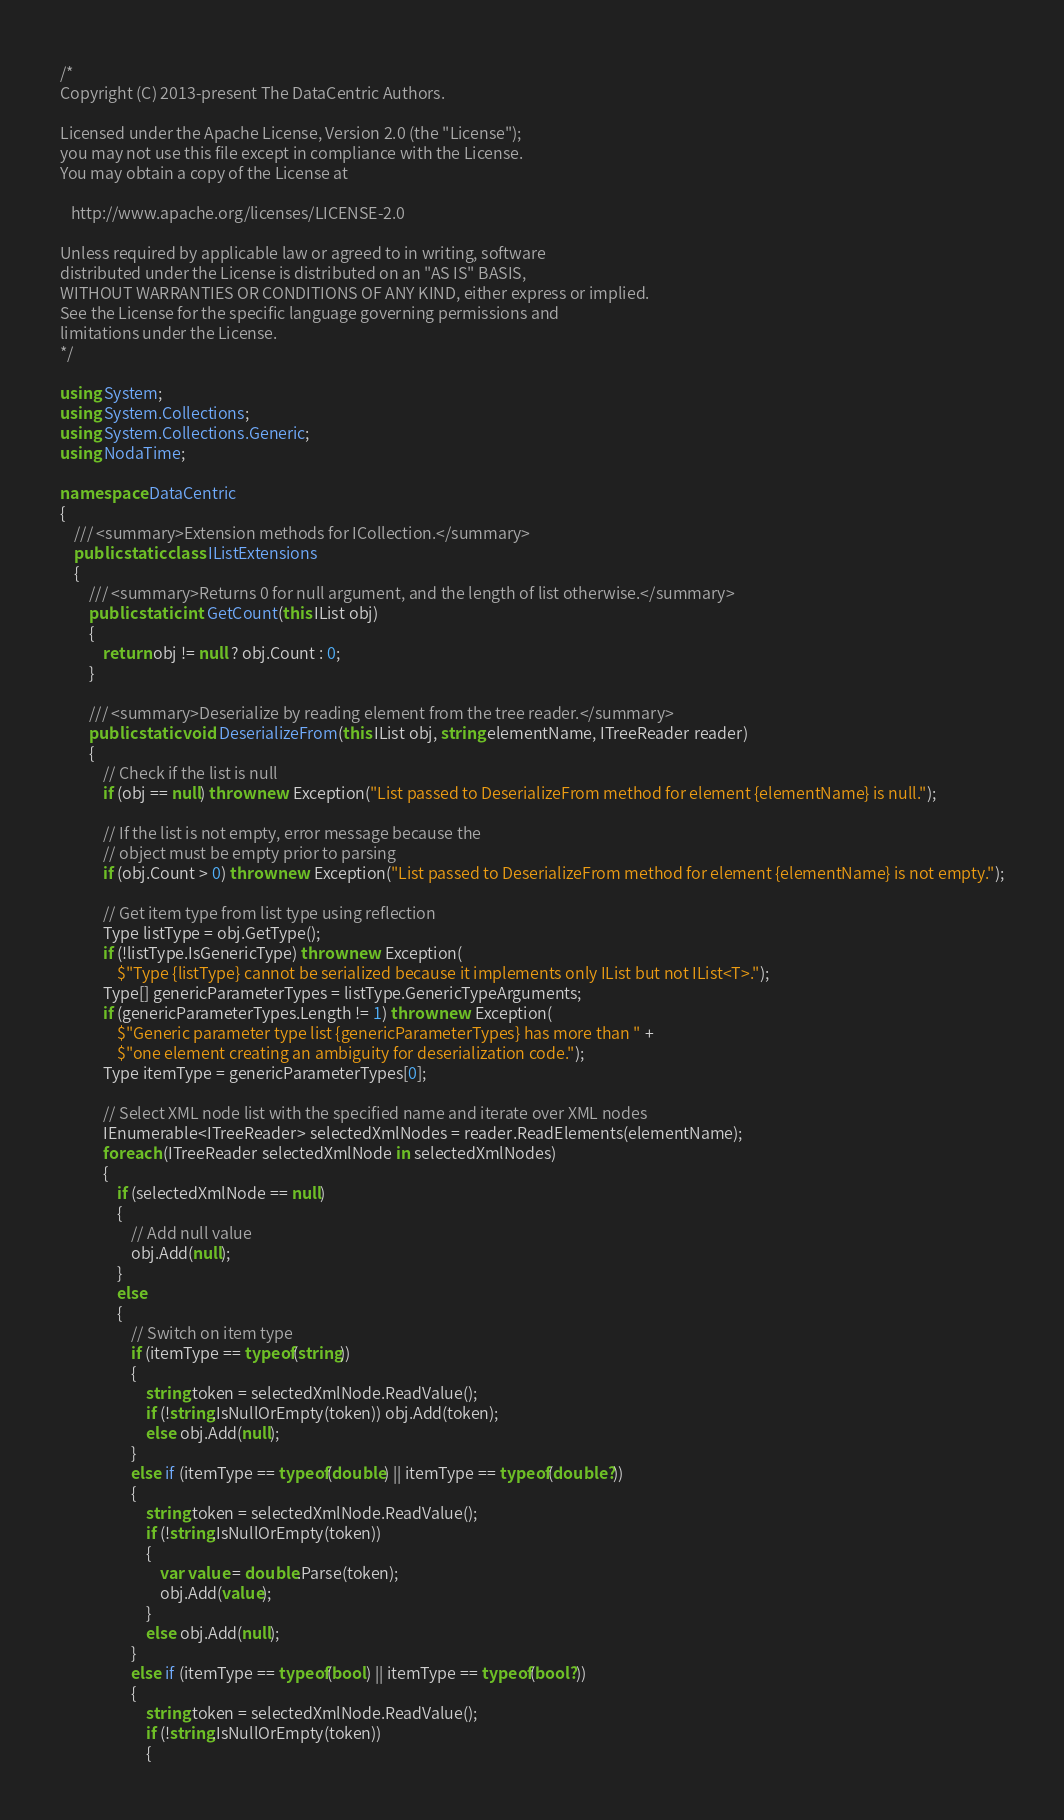<code> <loc_0><loc_0><loc_500><loc_500><_C#_>/*
Copyright (C) 2013-present The DataCentric Authors.

Licensed under the Apache License, Version 2.0 (the "License");
you may not use this file except in compliance with the License.
You may obtain a copy of the License at

   http://www.apache.org/licenses/LICENSE-2.0

Unless required by applicable law or agreed to in writing, software
distributed under the License is distributed on an "AS IS" BASIS,
WITHOUT WARRANTIES OR CONDITIONS OF ANY KIND, either express or implied.
See the License for the specific language governing permissions and
limitations under the License.
*/

using System;
using System.Collections;
using System.Collections.Generic;
using NodaTime;

namespace DataCentric
{
    /// <summary>Extension methods for ICollection.</summary>
    public static class IListExtensions
    {
        /// <summary>Returns 0 for null argument, and the length of list otherwise.</summary>
        public static int GetCount(this IList obj)
        {
            return obj != null ? obj.Count : 0;
        }

        /// <summary>Deserialize by reading element from the tree reader.</summary>
        public static void DeserializeFrom(this IList obj, string elementName, ITreeReader reader)
        {
            // Check if the list is null
            if (obj == null) throw new Exception("List passed to DeserializeFrom method for element {elementName} is null.");

            // If the list is not empty, error message because the
            // object must be empty prior to parsing
            if (obj.Count > 0) throw new Exception("List passed to DeserializeFrom method for element {elementName} is not empty.");

            // Get item type from list type using reflection
            Type listType = obj.GetType();
            if (!listType.IsGenericType) throw new Exception(
                $"Type {listType} cannot be serialized because it implements only IList but not IList<T>.");
            Type[] genericParameterTypes = listType.GenericTypeArguments;
            if (genericParameterTypes.Length != 1) throw new Exception(
                $"Generic parameter type list {genericParameterTypes} has more than " +
                $"one element creating an ambiguity for deserialization code.");
            Type itemType = genericParameterTypes[0];

            // Select XML node list with the specified name and iterate over XML nodes
            IEnumerable<ITreeReader> selectedXmlNodes = reader.ReadElements(elementName);
            foreach (ITreeReader selectedXmlNode in selectedXmlNodes)
            {
                if (selectedXmlNode == null)
                {
                    // Add null value
                    obj.Add(null);
                }
                else
                {
                    // Switch on item type
                    if (itemType == typeof(string))
                    {
                        string token = selectedXmlNode.ReadValue();
                        if (!string.IsNullOrEmpty(token)) obj.Add(token);
                        else obj.Add(null);
                    }
                    else if (itemType == typeof(double) || itemType == typeof(double?))
                    {
                        string token = selectedXmlNode.ReadValue();
                        if (!string.IsNullOrEmpty(token))
                        {
                            var value = double.Parse(token);
                            obj.Add(value);
                        }
                        else obj.Add(null);
                    }
                    else if (itemType == typeof(bool) || itemType == typeof(bool?))
                    {
                        string token = selectedXmlNode.ReadValue();
                        if (!string.IsNullOrEmpty(token))
                        {</code> 